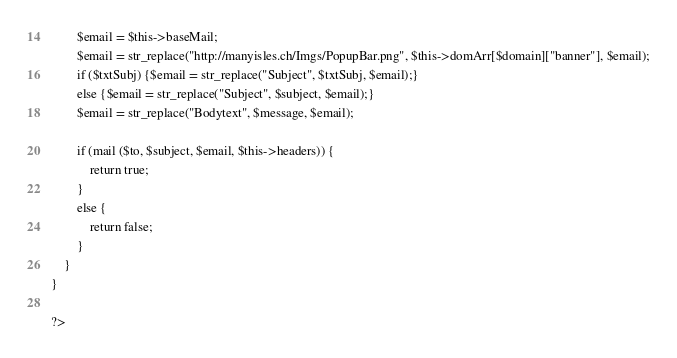<code> <loc_0><loc_0><loc_500><loc_500><_PHP_>        $email = $this->baseMail;
        $email = str_replace("http://manyisles.ch/Imgs/PopupBar.png", $this->domArr[$domain]["banner"], $email);
        if ($txtSubj) {$email = str_replace("Subject", $txtSubj, $email);}
        else {$email = str_replace("Subject", $subject, $email);}
        $email = str_replace("Bodytext", $message, $email);

        if (mail ($to, $subject, $email, $this->headers)) {
            return true;
        }
        else {
            return false;
        }
    }
}

?>
</code> 